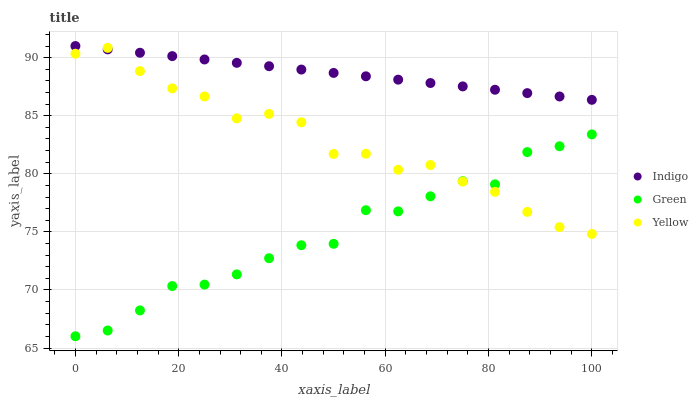Does Green have the minimum area under the curve?
Answer yes or no. Yes. Does Indigo have the maximum area under the curve?
Answer yes or no. Yes. Does Yellow have the minimum area under the curve?
Answer yes or no. No. Does Yellow have the maximum area under the curve?
Answer yes or no. No. Is Indigo the smoothest?
Answer yes or no. Yes. Is Green the roughest?
Answer yes or no. Yes. Is Yellow the smoothest?
Answer yes or no. No. Is Yellow the roughest?
Answer yes or no. No. Does Green have the lowest value?
Answer yes or no. Yes. Does Yellow have the lowest value?
Answer yes or no. No. Does Indigo have the highest value?
Answer yes or no. Yes. Does Yellow have the highest value?
Answer yes or no. No. Is Green less than Indigo?
Answer yes or no. Yes. Is Indigo greater than Green?
Answer yes or no. Yes. Does Yellow intersect Green?
Answer yes or no. Yes. Is Yellow less than Green?
Answer yes or no. No. Is Yellow greater than Green?
Answer yes or no. No. Does Green intersect Indigo?
Answer yes or no. No. 